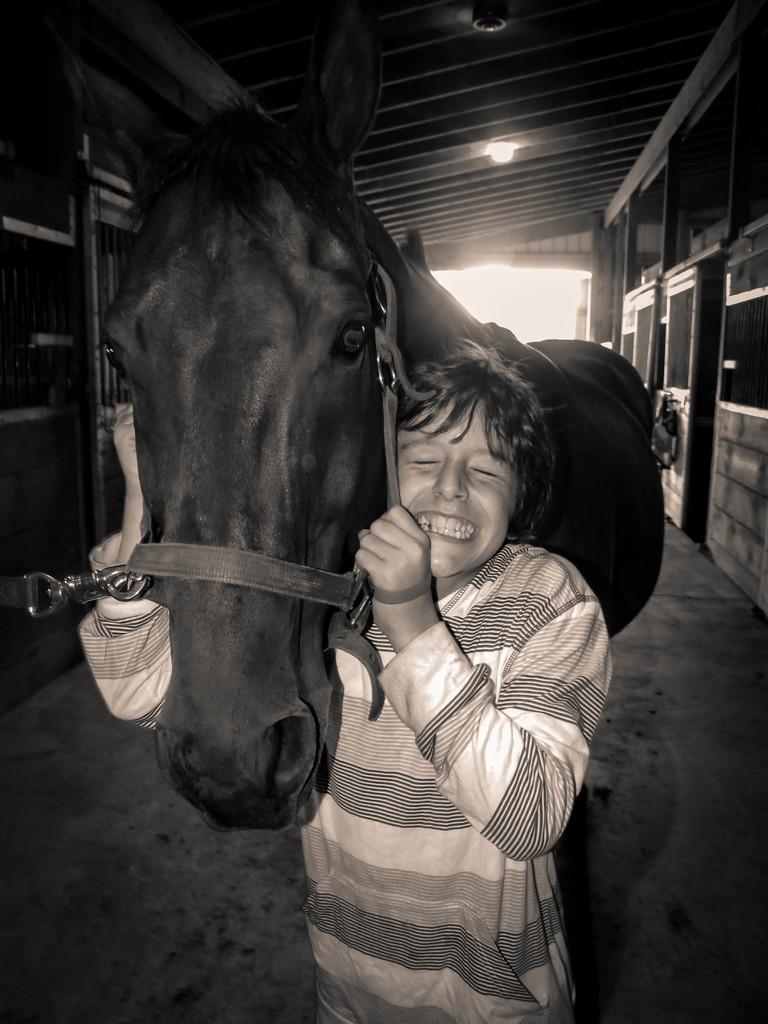Can you describe this image briefly? There is a man holding a horse and laughing in a room. 